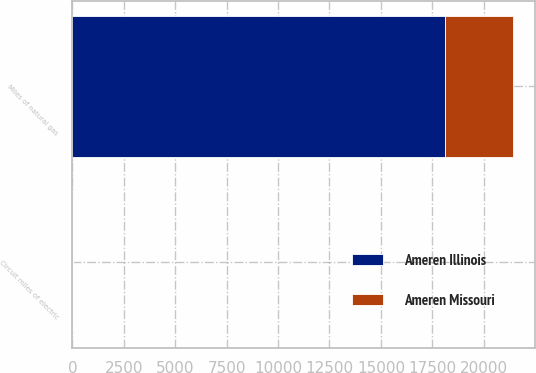<chart> <loc_0><loc_0><loc_500><loc_500><stacked_bar_chart><ecel><fcel>Circuit miles of electric<fcel>Miles of natural gas<nl><fcel>Ameren Missouri<fcel>23<fcel>3275<nl><fcel>Ameren Illinois<fcel>15<fcel>18126<nl></chart> 